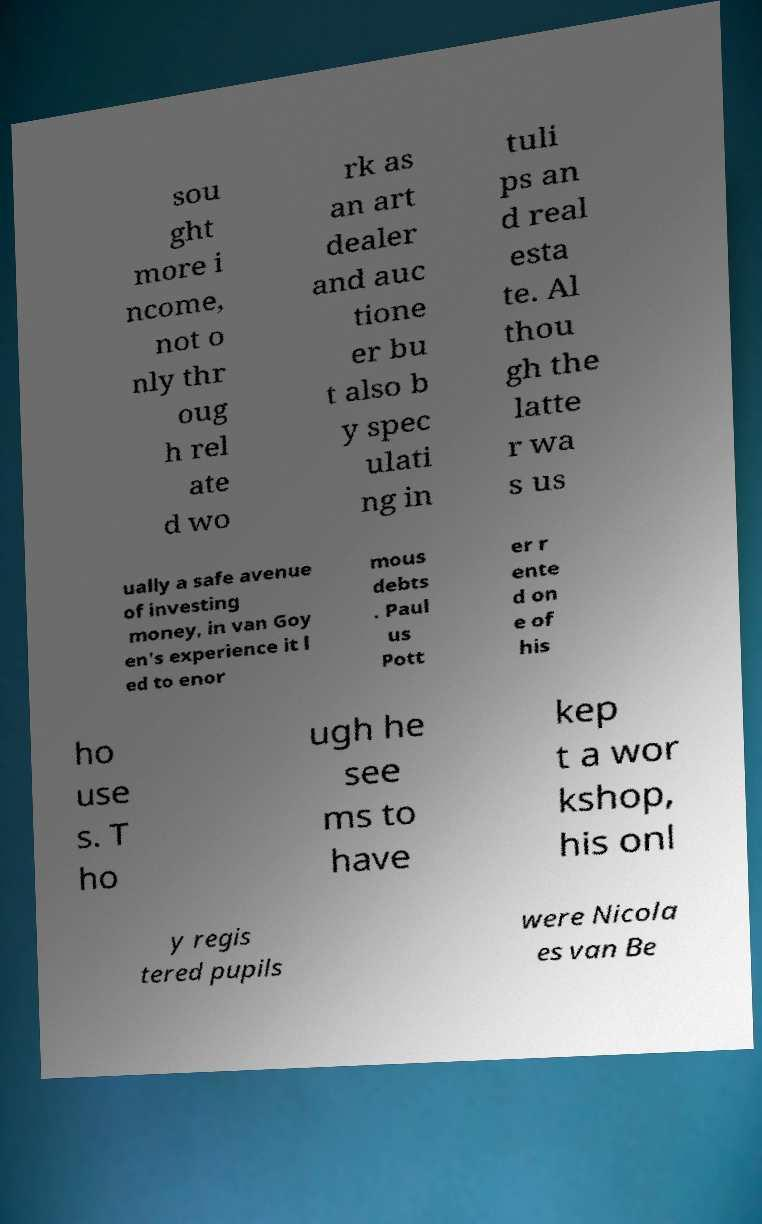I need the written content from this picture converted into text. Can you do that? sou ght more i ncome, not o nly thr oug h rel ate d wo rk as an art dealer and auc tione er bu t also b y spec ulati ng in tuli ps an d real esta te. Al thou gh the latte r wa s us ually a safe avenue of investing money, in van Goy en's experience it l ed to enor mous debts . Paul us Pott er r ente d on e of his ho use s. T ho ugh he see ms to have kep t a wor kshop, his onl y regis tered pupils were Nicola es van Be 